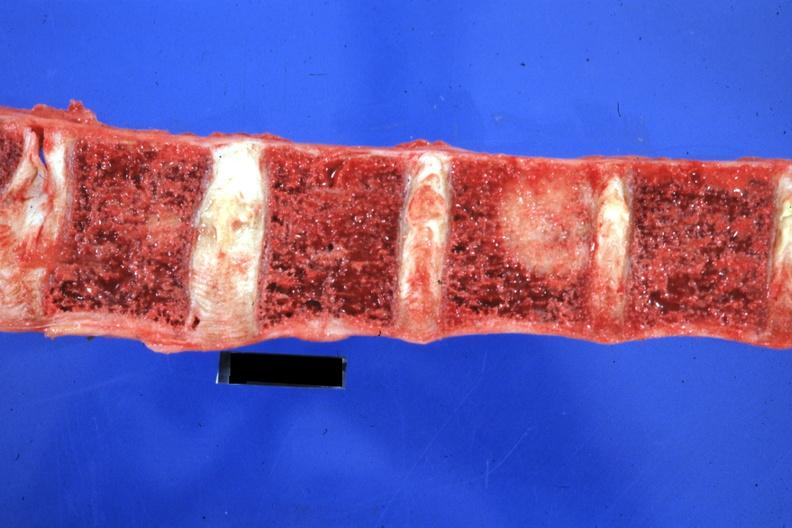s lateral view of head with ear lobe crease and web neck other photos in file present?
Answer the question using a single word or phrase. No 